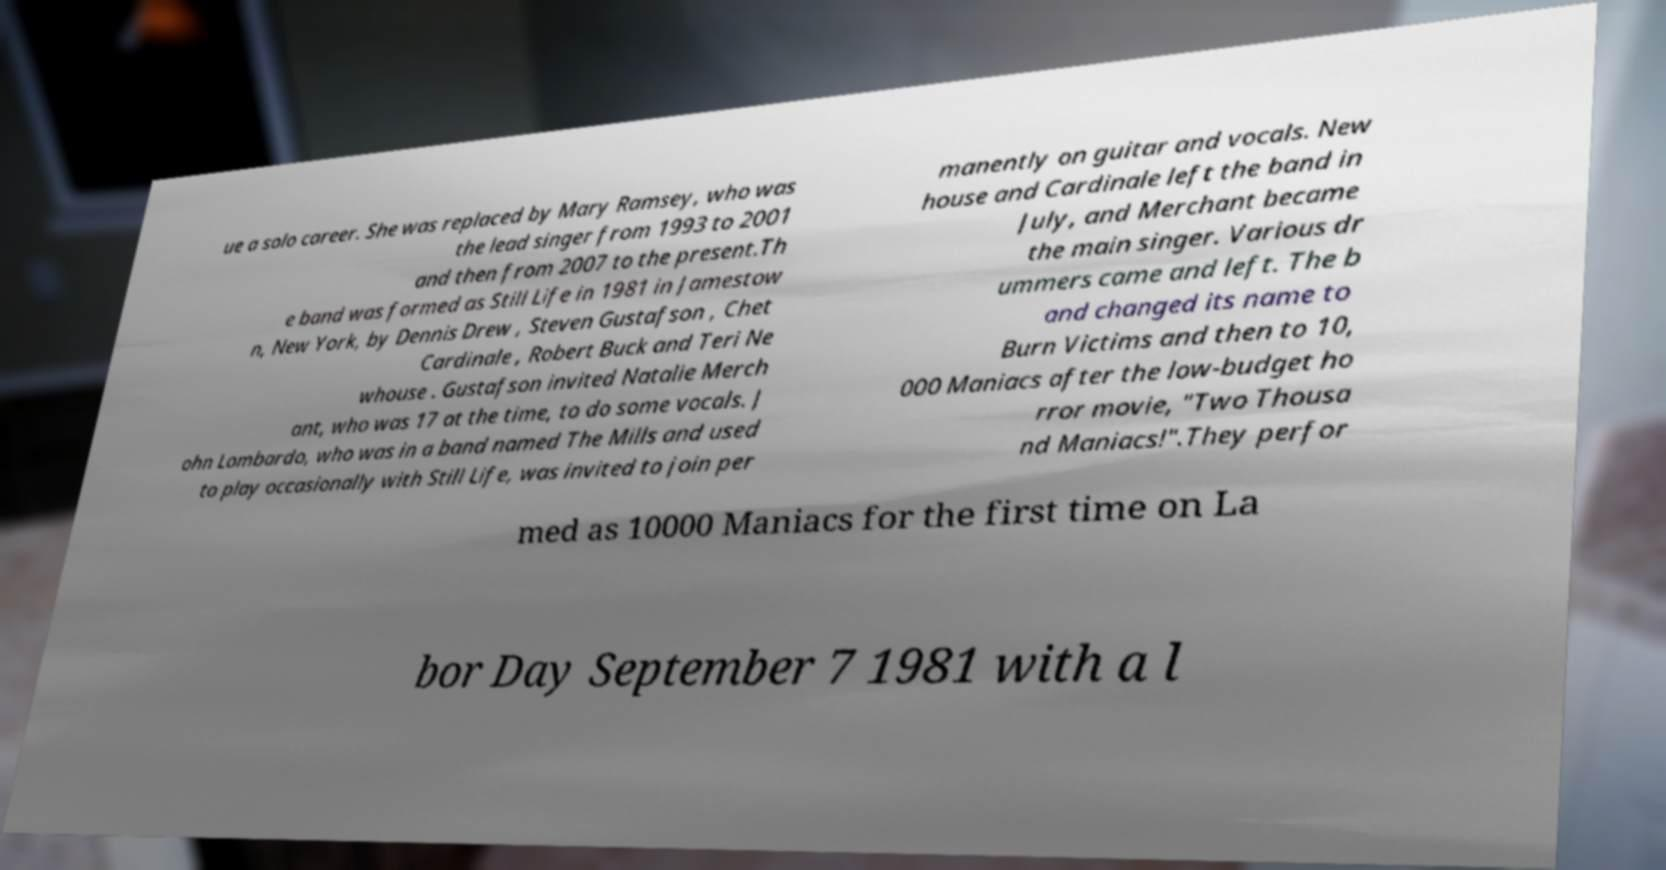Please read and relay the text visible in this image. What does it say? ue a solo career. She was replaced by Mary Ramsey, who was the lead singer from 1993 to 2001 and then from 2007 to the present.Th e band was formed as Still Life in 1981 in Jamestow n, New York, by Dennis Drew , Steven Gustafson , Chet Cardinale , Robert Buck and Teri Ne whouse . Gustafson invited Natalie Merch ant, who was 17 at the time, to do some vocals. J ohn Lombardo, who was in a band named The Mills and used to play occasionally with Still Life, was invited to join per manently on guitar and vocals. New house and Cardinale left the band in July, and Merchant became the main singer. Various dr ummers came and left. The b and changed its name to Burn Victims and then to 10, 000 Maniacs after the low-budget ho rror movie, "Two Thousa nd Maniacs!".They perfor med as 10000 Maniacs for the first time on La bor Day September 7 1981 with a l 